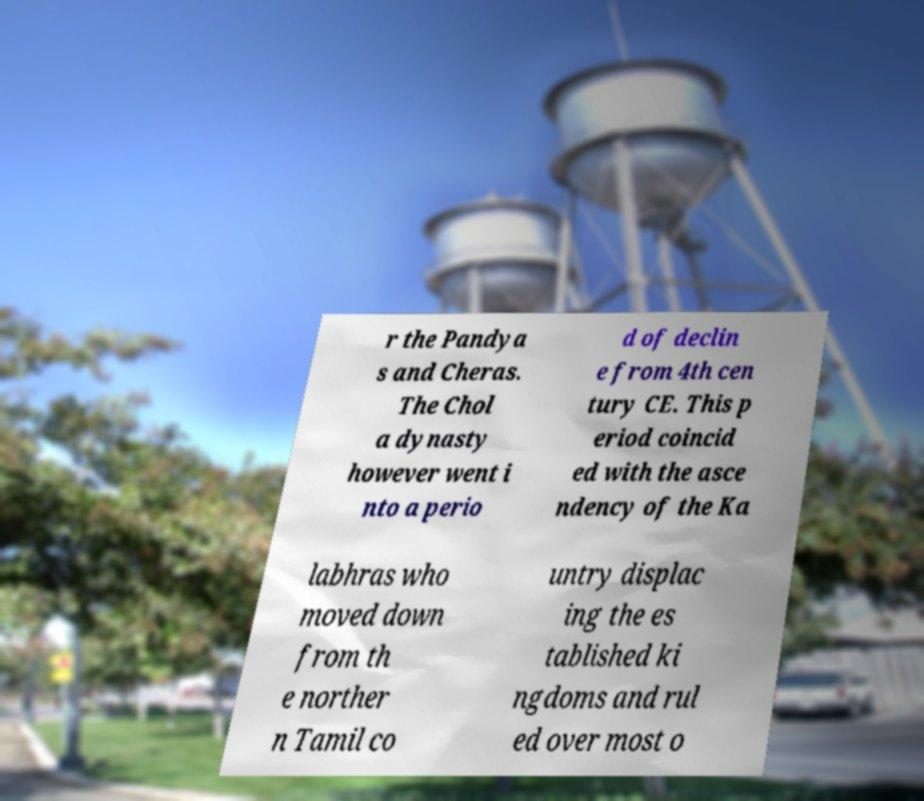Can you accurately transcribe the text from the provided image for me? r the Pandya s and Cheras. The Chol a dynasty however went i nto a perio d of declin e from 4th cen tury CE. This p eriod coincid ed with the asce ndency of the Ka labhras who moved down from th e norther n Tamil co untry displac ing the es tablished ki ngdoms and rul ed over most o 